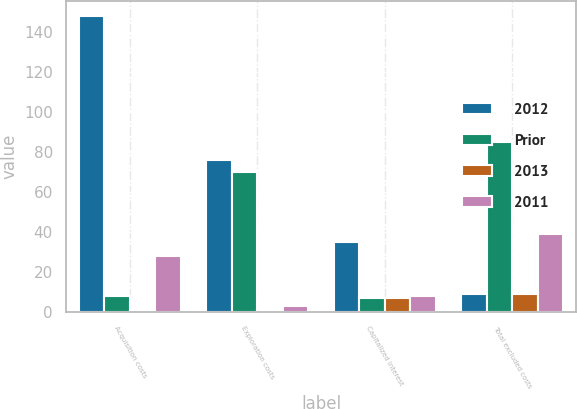<chart> <loc_0><loc_0><loc_500><loc_500><stacked_bar_chart><ecel><fcel>Acquisition costs<fcel>Exploration costs<fcel>Capitalized interest<fcel>Total excluded costs<nl><fcel>2012<fcel>148<fcel>76<fcel>35<fcel>9<nl><fcel>Prior<fcel>8<fcel>70<fcel>7<fcel>85<nl><fcel>2013<fcel>1<fcel>1<fcel>7<fcel>9<nl><fcel>2011<fcel>28<fcel>3<fcel>8<fcel>39<nl></chart> 